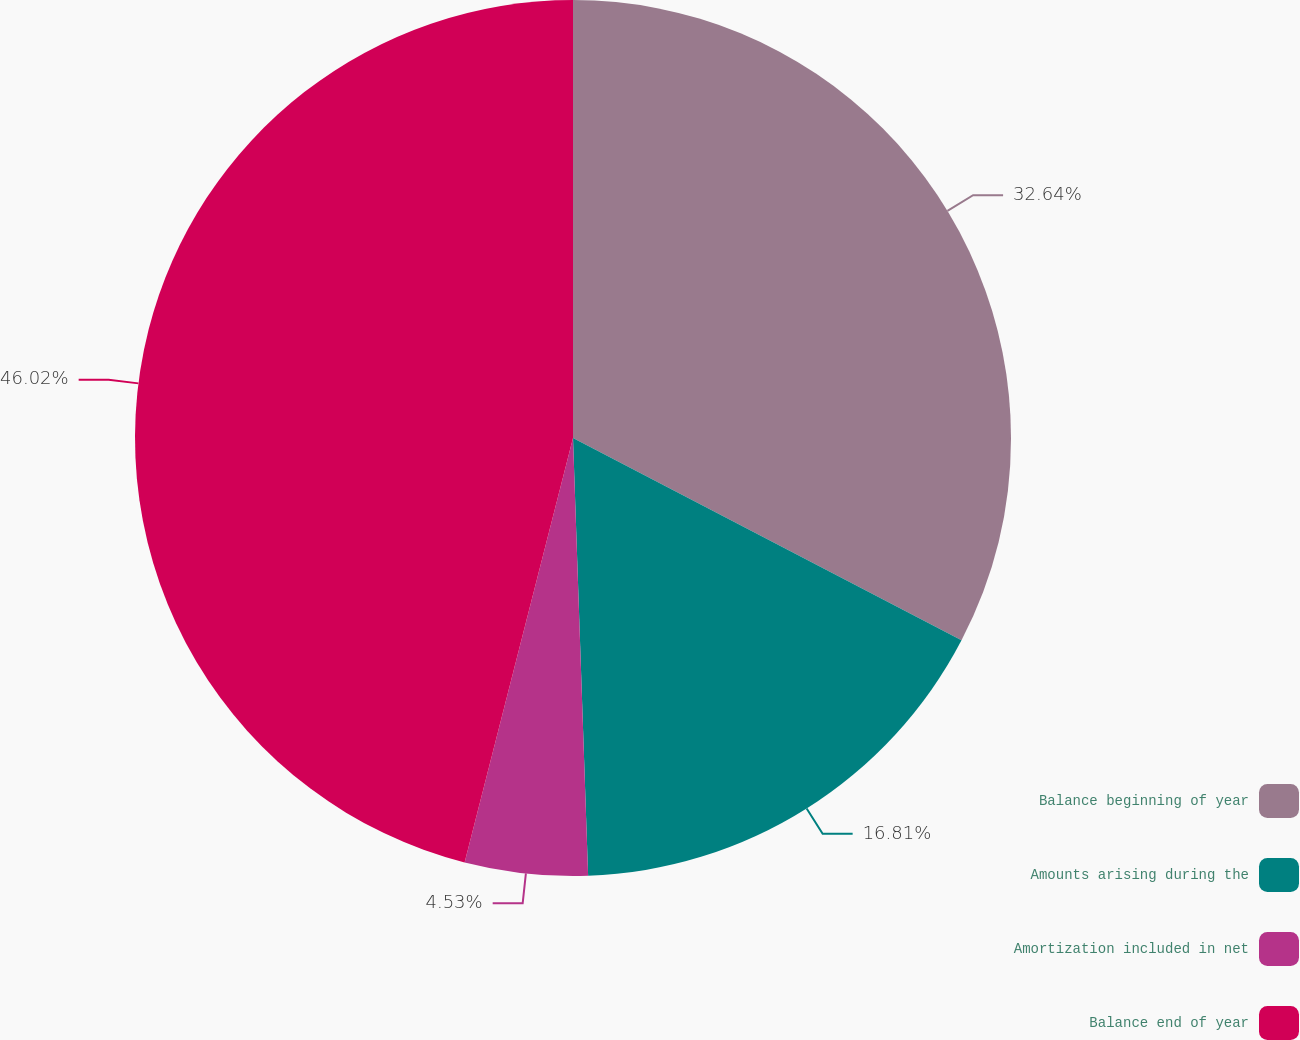Convert chart to OTSL. <chart><loc_0><loc_0><loc_500><loc_500><pie_chart><fcel>Balance beginning of year<fcel>Amounts arising during the<fcel>Amortization included in net<fcel>Balance end of year<nl><fcel>32.64%<fcel>16.81%<fcel>4.53%<fcel>46.02%<nl></chart> 